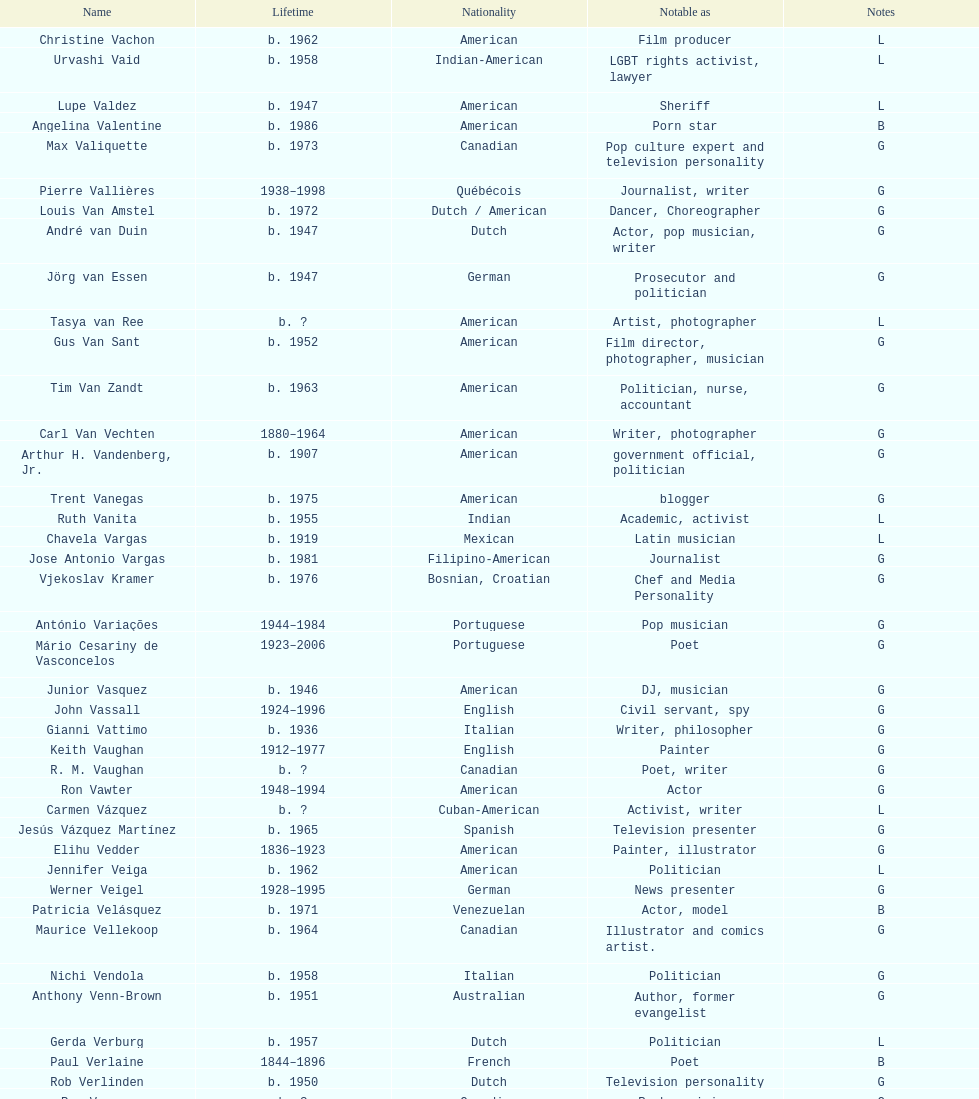Who lived longer, van vechten or variacoes? Van Vechten. 